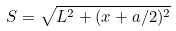<formula> <loc_0><loc_0><loc_500><loc_500>S = \sqrt { L ^ { 2 } + ( x + a / 2 ) ^ { 2 } }</formula> 